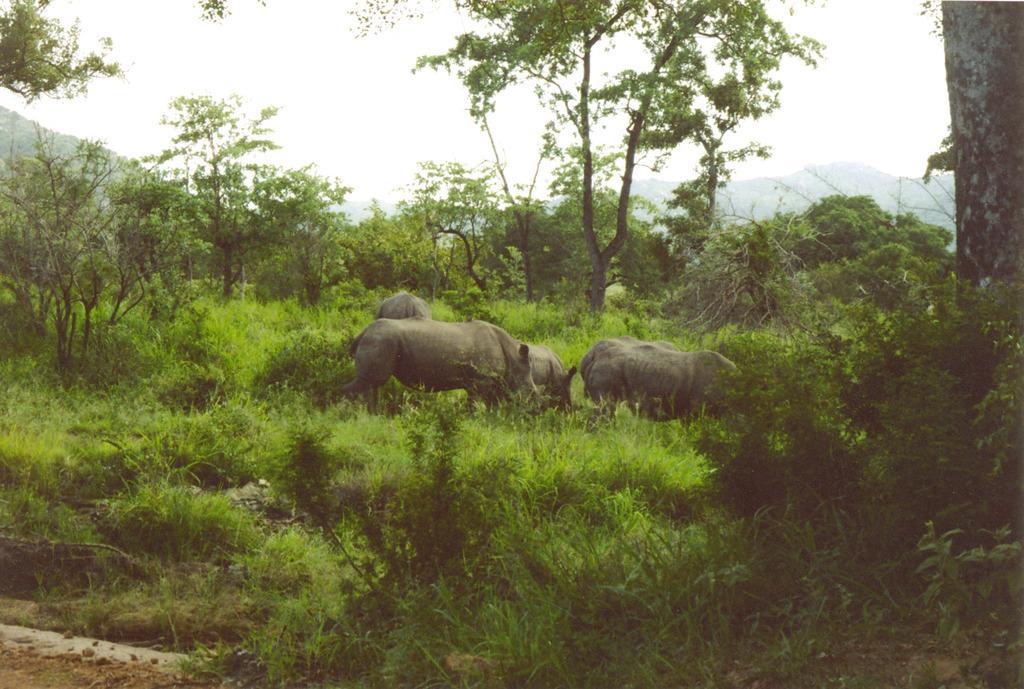Describe this image in one or two sentences. In the center of the image we can see some animals. We can also see some grass, plants, the bark of a tree and a group of trees. On the backside we can see the hills and the sky which looks cloudy. 